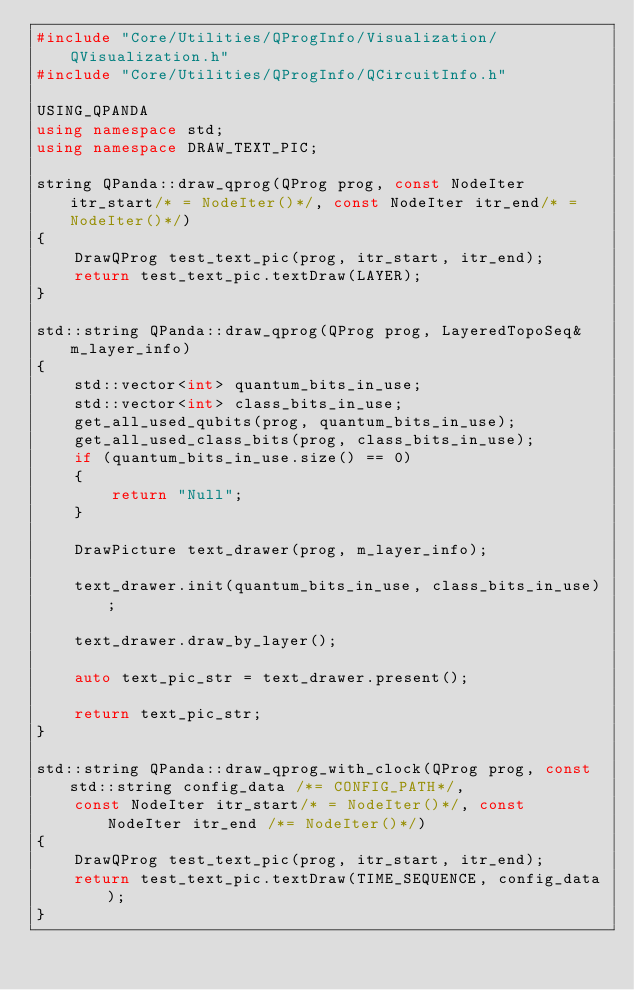Convert code to text. <code><loc_0><loc_0><loc_500><loc_500><_C++_>#include "Core/Utilities/QProgInfo/Visualization/QVisualization.h"
#include "Core/Utilities/QProgInfo/QCircuitInfo.h"

USING_QPANDA
using namespace std;
using namespace DRAW_TEXT_PIC;

string QPanda::draw_qprog(QProg prog, const NodeIter itr_start/* = NodeIter()*/, const NodeIter itr_end/* = NodeIter()*/)
{
	DrawQProg test_text_pic(prog, itr_start, itr_end);
	return test_text_pic.textDraw(LAYER);
}

std::string QPanda::draw_qprog(QProg prog, LayeredTopoSeq& m_layer_info)
{
	std::vector<int> quantum_bits_in_use;
	std::vector<int> class_bits_in_use;
	get_all_used_qubits(prog, quantum_bits_in_use);
	get_all_used_class_bits(prog, class_bits_in_use);
	if (quantum_bits_in_use.size() == 0)
	{
		return "Null";
	}

	DrawPicture text_drawer(prog, m_layer_info);

	text_drawer.init(quantum_bits_in_use, class_bits_in_use);

	text_drawer.draw_by_layer();

	auto text_pic_str = text_drawer.present();

	return text_pic_str;
}

std::string QPanda::draw_qprog_with_clock(QProg prog, const std::string config_data /*= CONFIG_PATH*/, 
	const NodeIter itr_start/* = NodeIter()*/, const NodeIter itr_end /*= NodeIter()*/)
{
	DrawQProg test_text_pic(prog, itr_start, itr_end);
	return test_text_pic.textDraw(TIME_SEQUENCE, config_data);
}
</code> 